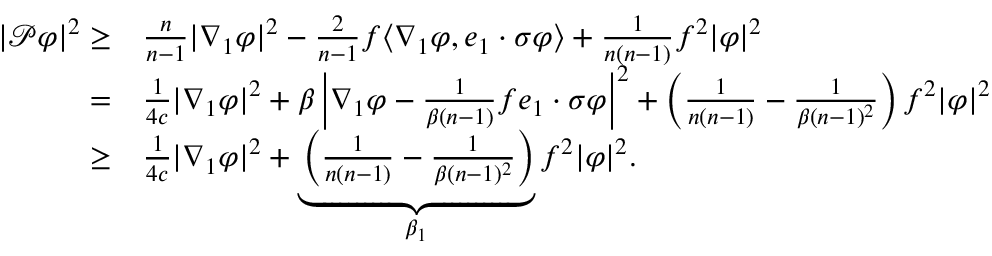<formula> <loc_0><loc_0><loc_500><loc_500>\begin{array} { r l } { | \mathcal { P } \varphi | ^ { 2 } \geq } & { \frac { n } { n - 1 } | \nabla _ { 1 } \varphi | ^ { 2 } - \frac { 2 } { n - 1 } f \langle \nabla _ { 1 } \varphi , e _ { 1 } \cdot \sigma \varphi \rangle + \frac { 1 } { n ( n - 1 ) } f ^ { 2 } | \varphi | ^ { 2 } } \\ { = } & { \frac { 1 } { 4 c } | \nabla _ { 1 } \varphi | ^ { 2 } + \beta \left | \nabla _ { 1 } \varphi - \frac { 1 } { \beta ( n - 1 ) } f e _ { 1 } \cdot \sigma \varphi \right | ^ { 2 } + \left ( \frac { 1 } { n ( n - 1 ) } - \frac { 1 } { \beta ( n - 1 ) ^ { 2 } } \right ) f ^ { 2 } | \varphi | ^ { 2 } } \\ { \geq } & { \frac { 1 } { 4 c } | \nabla _ { 1 } \varphi | ^ { 2 } + \underbrace { \left ( \frac { 1 } { n ( n - 1 ) } - \frac { 1 } { \beta ( n - 1 ) ^ { 2 } } \right ) } _ { \beta _ { 1 } } f ^ { 2 } | \varphi | ^ { 2 } . } \end{array}</formula> 